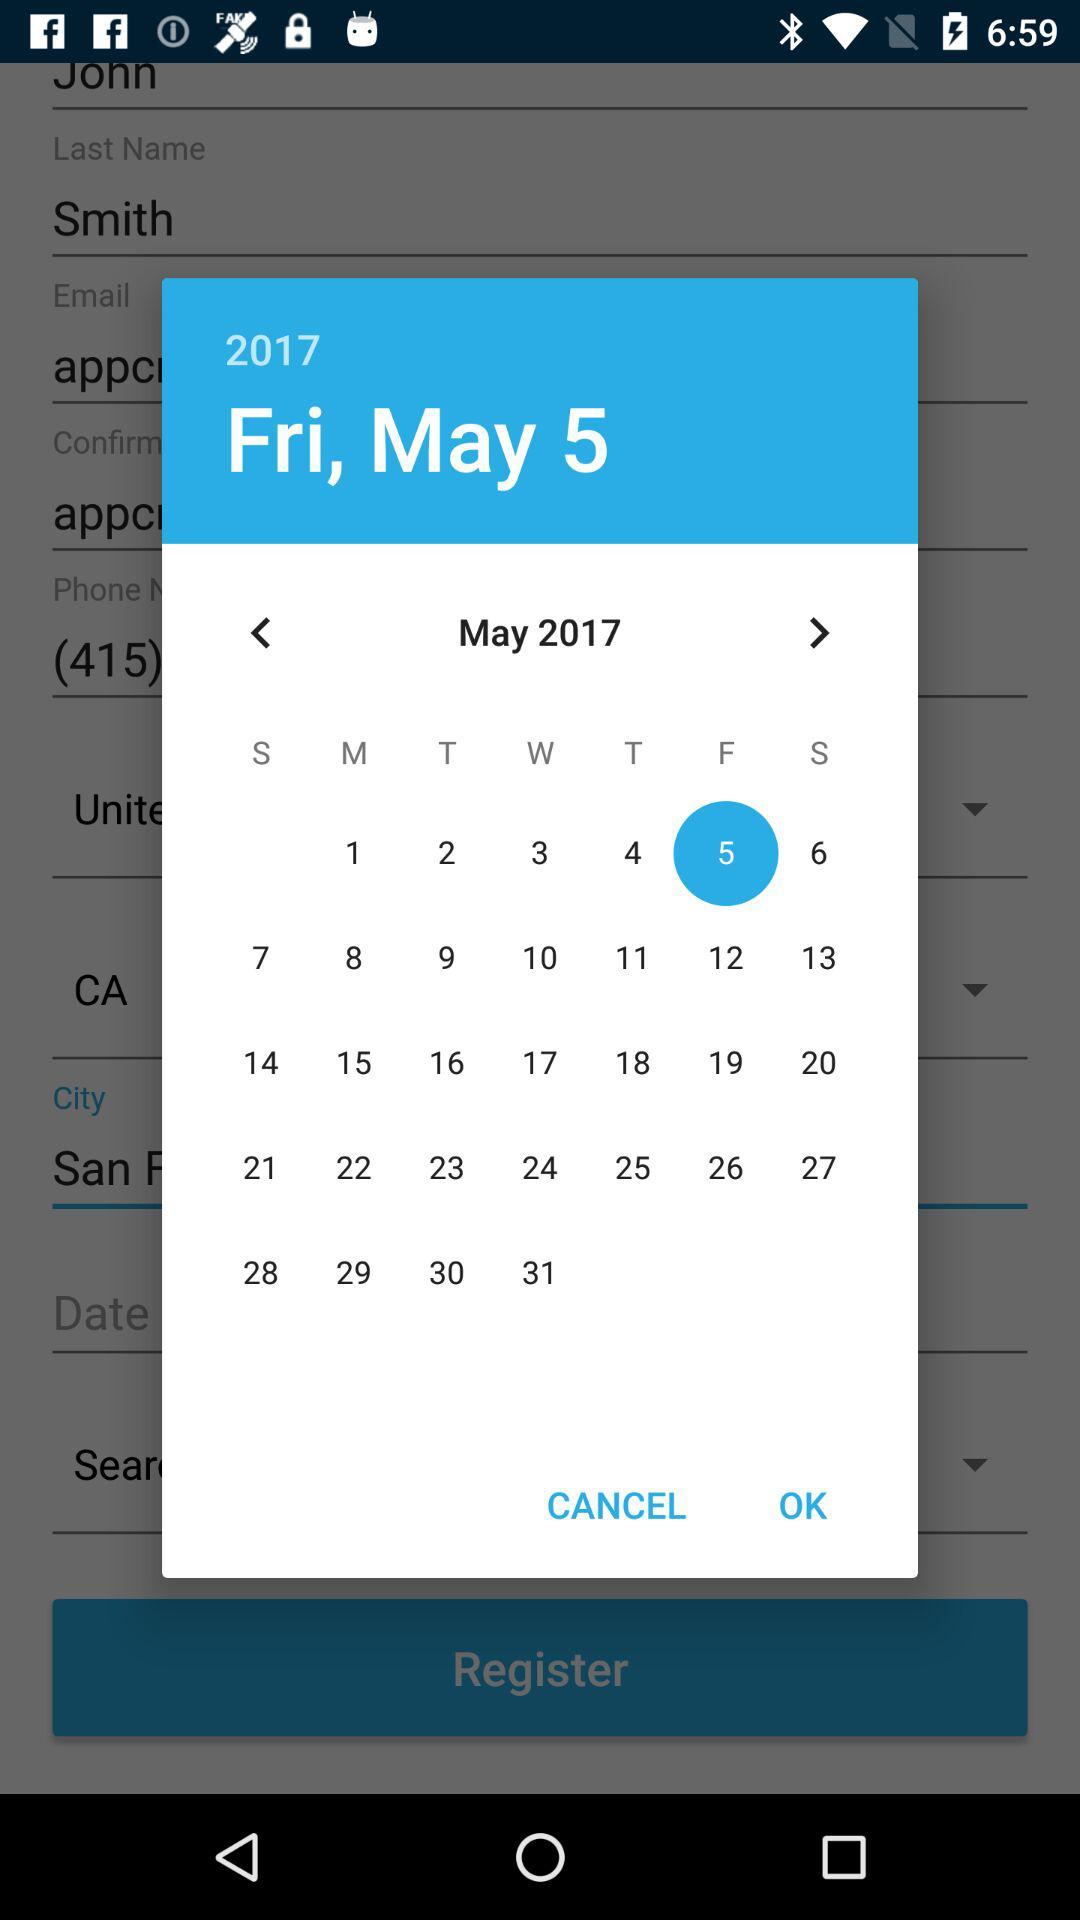What is the given month? The given month is May. 